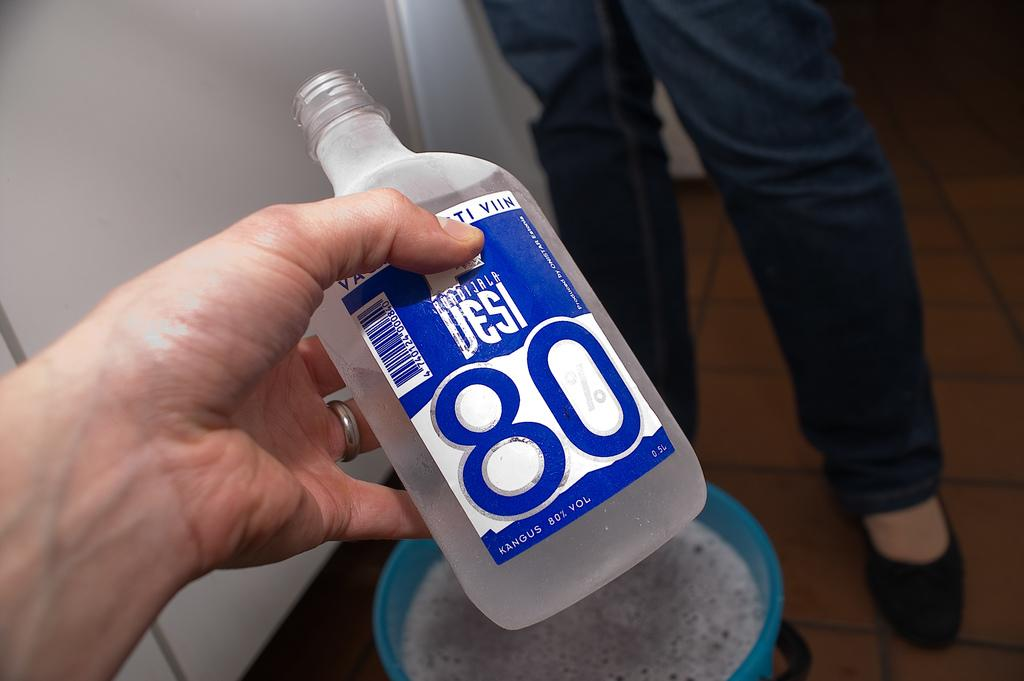Provide a one-sentence caption for the provided image. A clear bottle with a blue label of Desi 80% alcohol. 